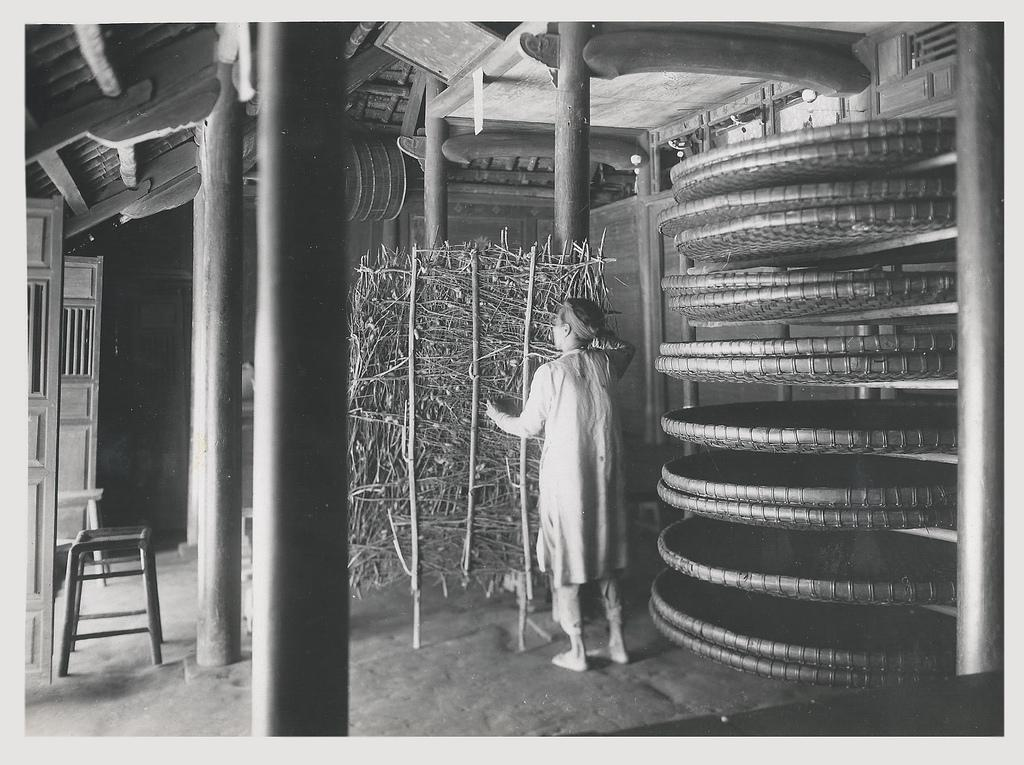What is the main subject of the image? There is a person standing in the image. What is the person standing in front of? The person is standing in front of an object. What else can be seen in the image? There is another object in the right corner of the image. Can you see the person's brain in the image? No, the person's brain is not visible in the image. Is the person touching the object in front of them? The image does not provide information about whether the person is touching the object or not. 